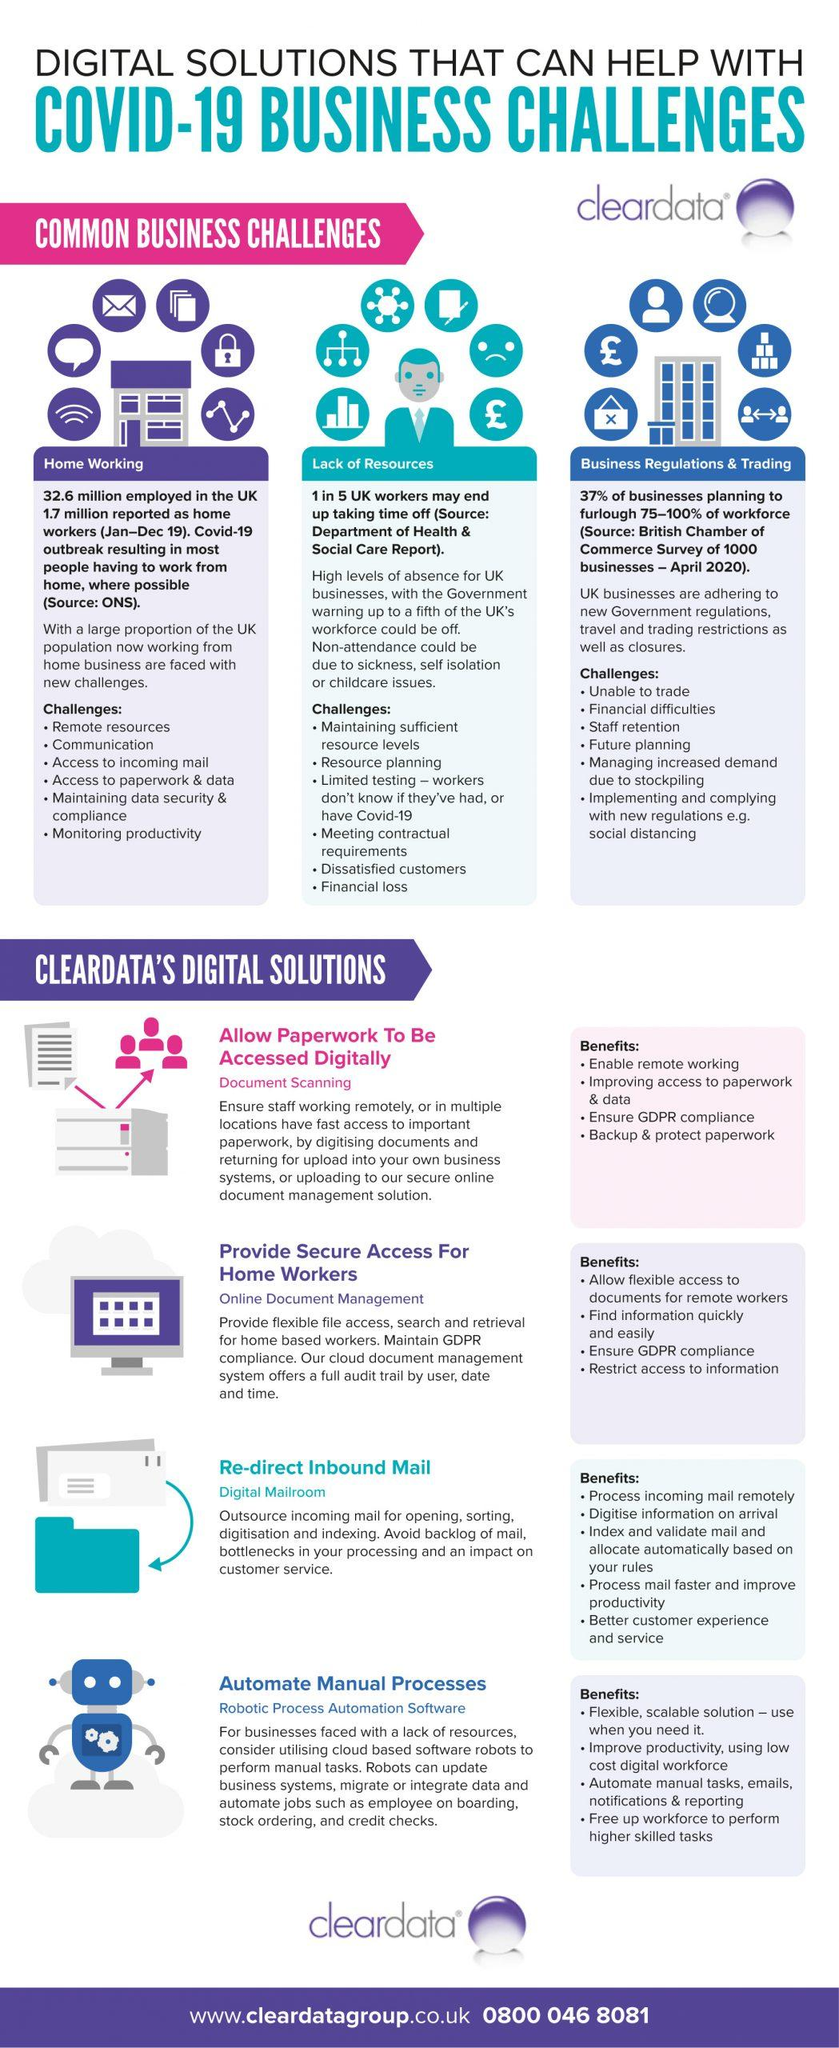Point out several critical features in this image. Common business challenges include home working, lack of resources, business regulations, and trading. 